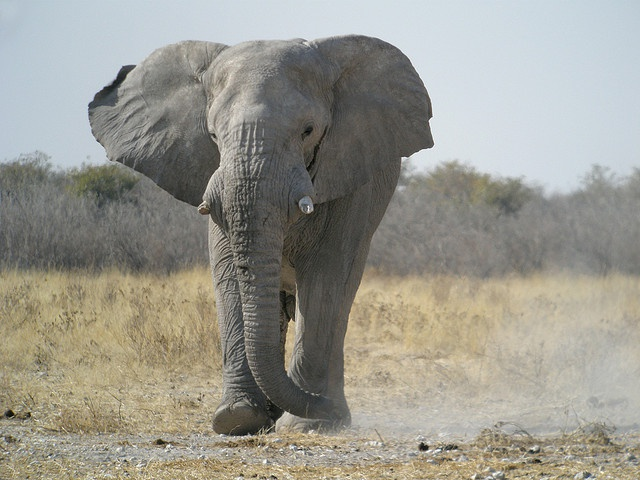Describe the objects in this image and their specific colors. I can see a elephant in lightblue, gray, darkgray, and black tones in this image. 